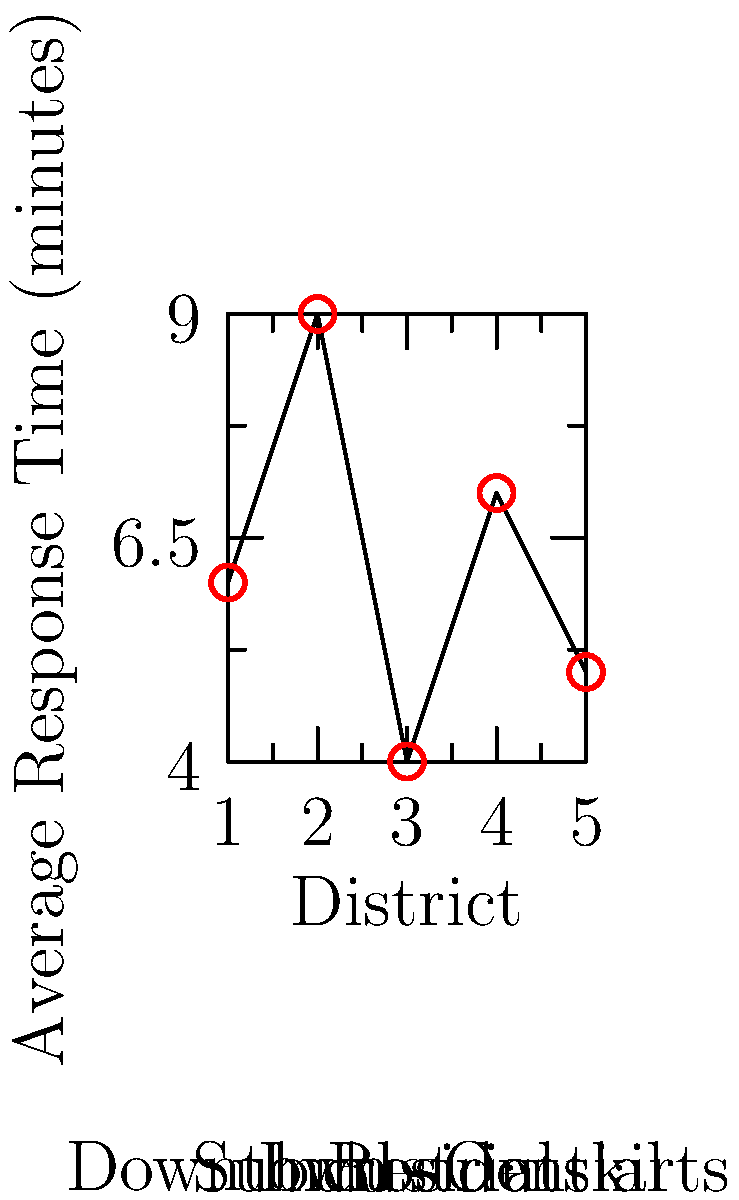As a local police officer concerned with community connections, you're analyzing emergency response times across different city areas. Based on the graph, which district has the longest average response time, and what factors might contribute to this? To answer this question, let's analyze the graph step-by-step:

1. The graph shows average response times for five different districts in the city.
2. The x-axis represents the districts: Downtown, Suburbs, Industrial, Residential, and Outskirts.
3. The y-axis represents the average response time in minutes.
4. Comparing the data points:
   - Downtown (District 1): 6 minutes
   - Suburbs (District 2): 9 minutes
   - Industrial (District 3): 4 minutes
   - Residential (District 4): 7 minutes
   - Outskirts (District 5): 5 minutes

5. The longest average response time is 9 minutes, corresponding to the Suburbs (District 2).

Factors that might contribute to longer response times in the suburbs:
a) Greater distance from central police stations
b) Lower density of police patrols
c) More spread-out residential areas
d) Possibly more complex road networks or traffic patterns
e) Fewer emergency service facilities compared to more densely populated areas

As a community-oriented police officer, understanding these factors can help in developing strategies to improve response times and strengthen community connections in the suburbs.
Answer: Suburbs; 9 minutes 